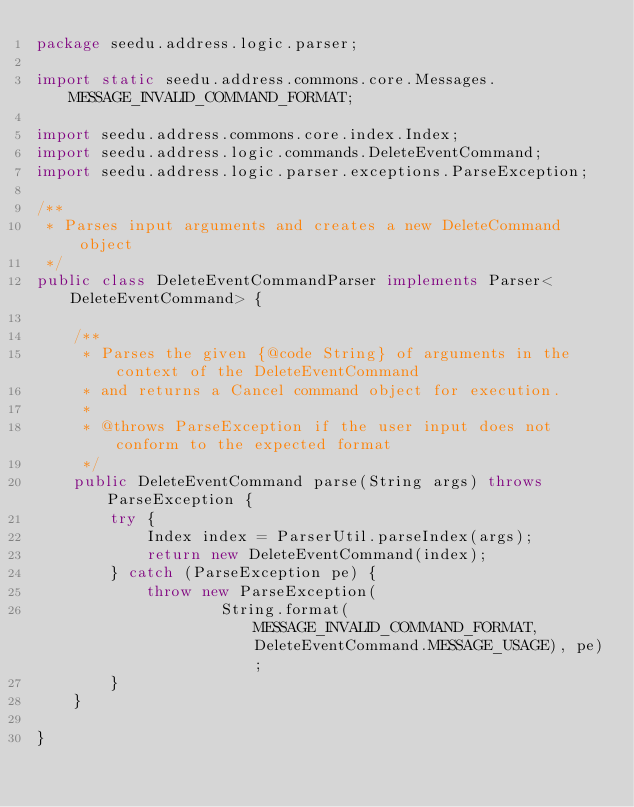Convert code to text. <code><loc_0><loc_0><loc_500><loc_500><_Java_>package seedu.address.logic.parser;

import static seedu.address.commons.core.Messages.MESSAGE_INVALID_COMMAND_FORMAT;

import seedu.address.commons.core.index.Index;
import seedu.address.logic.commands.DeleteEventCommand;
import seedu.address.logic.parser.exceptions.ParseException;

/**
 * Parses input arguments and creates a new DeleteCommand object
 */
public class DeleteEventCommandParser implements Parser<DeleteEventCommand> {

    /**
     * Parses the given {@code String} of arguments in the context of the DeleteEventCommand
     * and returns a Cancel command object for execution.
     *
     * @throws ParseException if the user input does not conform to the expected format
     */
    public DeleteEventCommand parse(String args) throws ParseException {
        try {
            Index index = ParserUtil.parseIndex(args);
            return new DeleteEventCommand(index);
        } catch (ParseException pe) {
            throw new ParseException(
                    String.format(MESSAGE_INVALID_COMMAND_FORMAT, DeleteEventCommand.MESSAGE_USAGE), pe);
        }
    }

}
</code> 